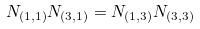Convert formula to latex. <formula><loc_0><loc_0><loc_500><loc_500>N _ { ( 1 , 1 ) } N _ { ( 3 , 1 ) } = N _ { ( 1 , 3 ) } N _ { ( 3 , 3 ) }</formula> 